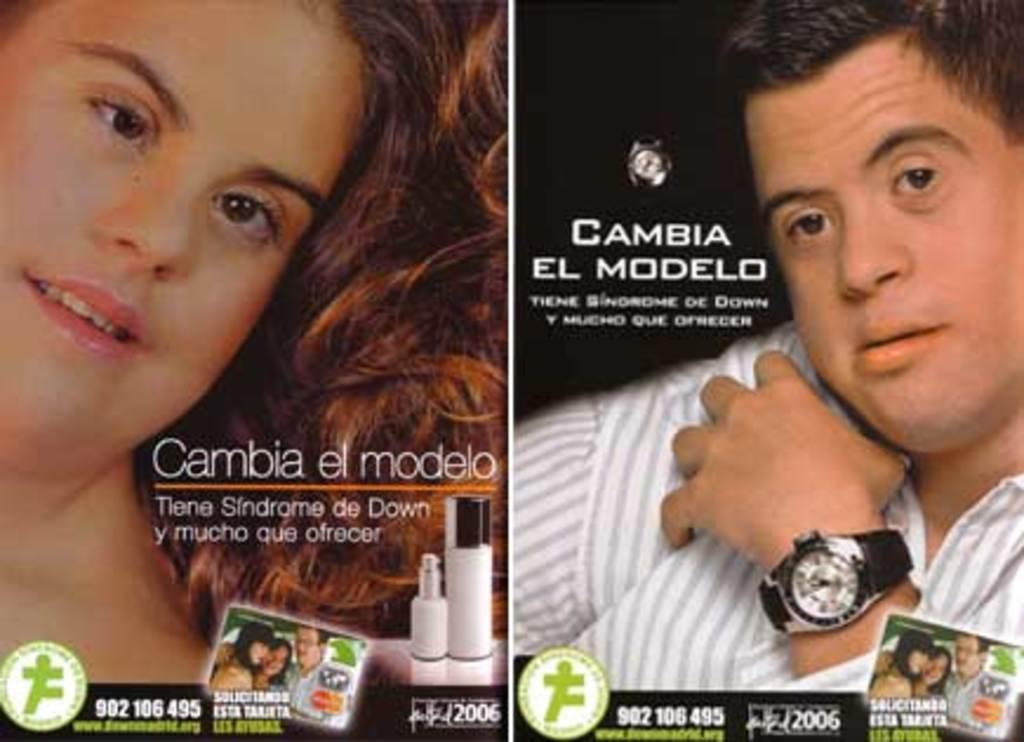<image>
Share a concise interpretation of the image provided. Two Down Sydrome models for "Cambia el Modelo" Down Syndrome campaign for DS sufferers. 